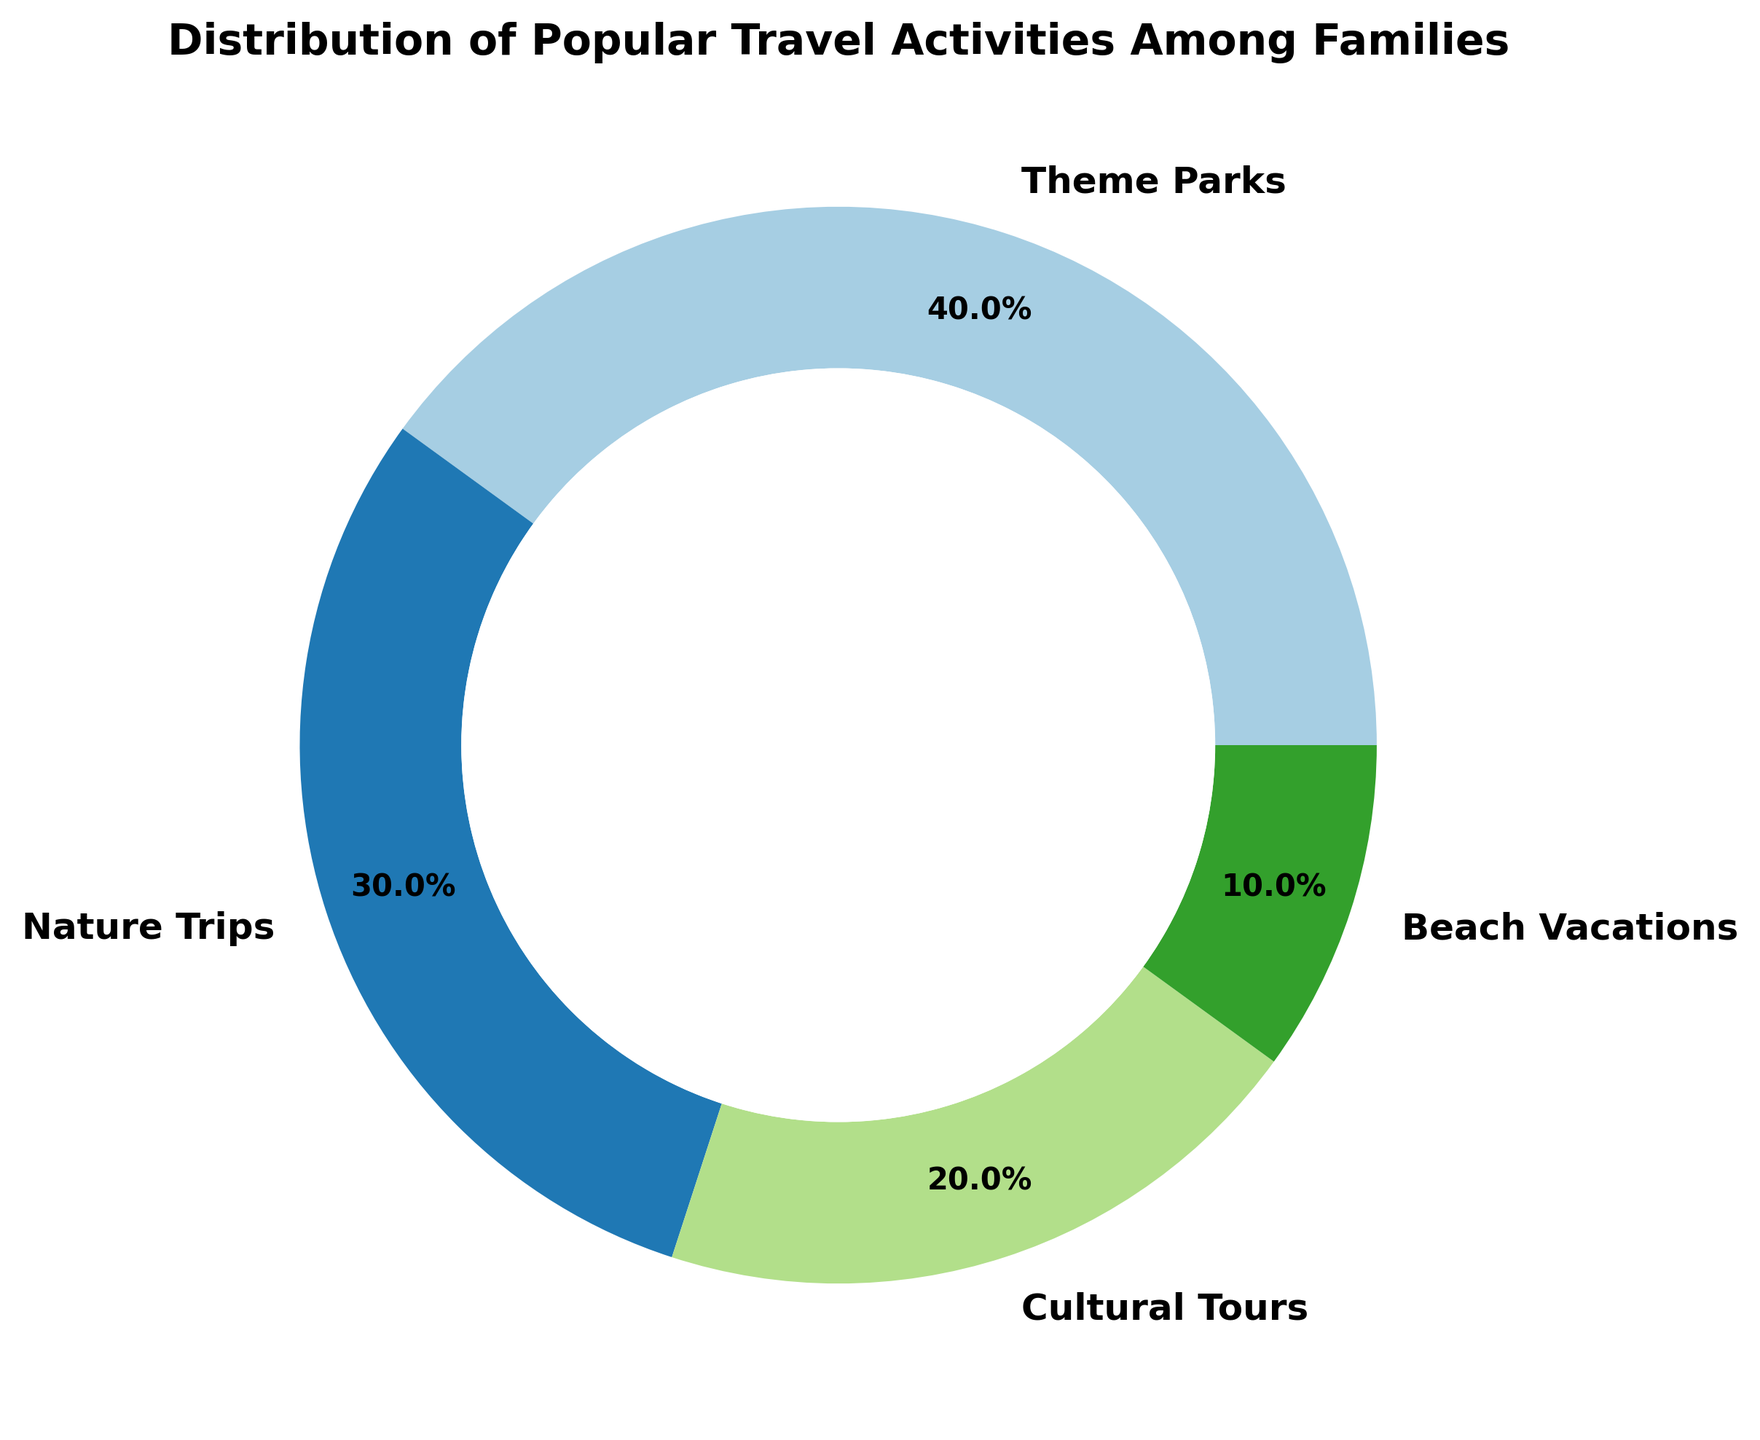What's the most popular travel activity among families? The ring chart shows the distribution of popular travel activities among families, with Theme Parks having the largest segment.
Answer: Theme Parks Which travel activity is least popular among families? The ring chart displays the distribution of travel activities, and the smallest segment corresponds to Beach Vacations.
Answer: Beach Vacations What is the difference in percentage points between Theme Parks and Nature Trips? Theme Parks have a percentage of 40%, and Nature Trips have 30%. The difference is 40% - 30%.
Answer: 10% Compare the combined percentage of Cultural Tours and Beach Vacations to that of Nature Trips. Cultural Tours have 20% and Beach Vacations have 10%. Their combined percentage is 20% + 10% = 30%, which is equal to Nature Trips at 30%.
Answer: Equal Which two travel activities together make up half of the distribution? Theme Parks have 40%, and Beach Vacations have 10%. Their combined percentage is 40% + 10% = 50%.
Answer: Theme Parks and Beach Vacations How many travel activities have a percentage greater than or equal to 20%? The chart shows percentages of 40% (Theme Parks), 30% (Nature Trips), 20% (Cultural Tours), and 10% (Beach Vacations). Three activities have percentages greater than or equal to 20%.
Answer: Three Which travel activity segments are visually equivalent in size? Looking at the ring chart, the segments for Nature Trips (30%) and Cultural Tours (20%) are different, but no two segments are visually equivalent in size.
Answer: None What's the average percentage of all the travel activities? The activities have percentages of 40%, 30%, 20%, and 10%. The average is (40 + 30 + 20 + 10) / 4 = 25%.
Answer: 25% What is the ratio of Theme Parks to Beach Vacations in terms of percentage? Theme Parks have 40% and Beach Vacations have 10%. The ratio of Theme Parks to Beach Vacations is 40:10, which simplifies to 4:1.
Answer: 4:1 